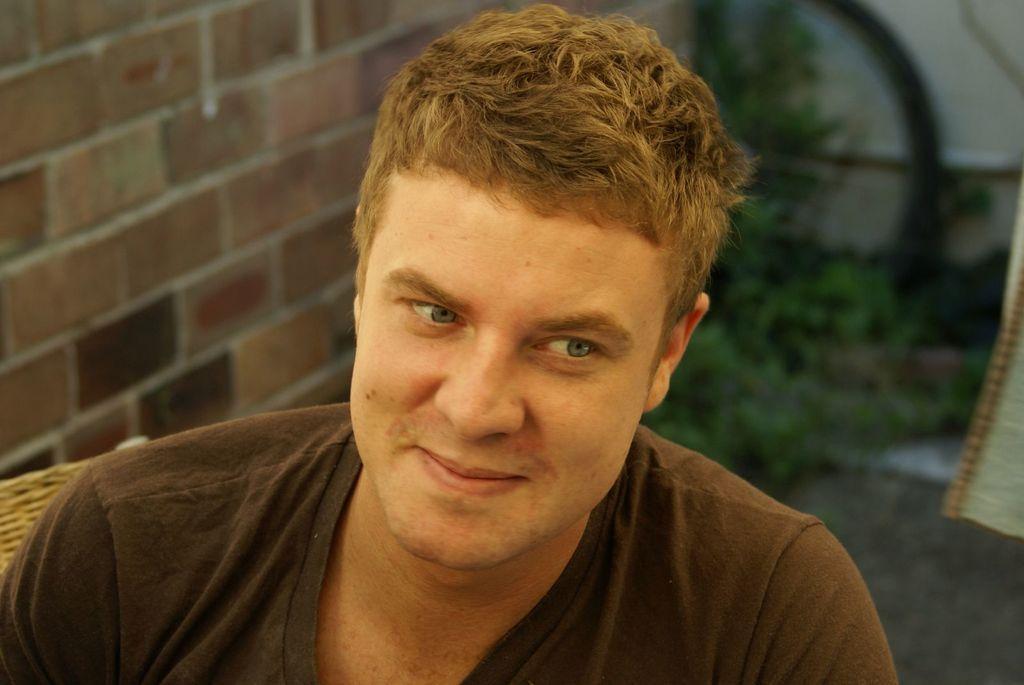Describe this image in one or two sentences. In this picture we can see a man smiling in the front, on the left side there is a brick wall, in the background we can see plants. 